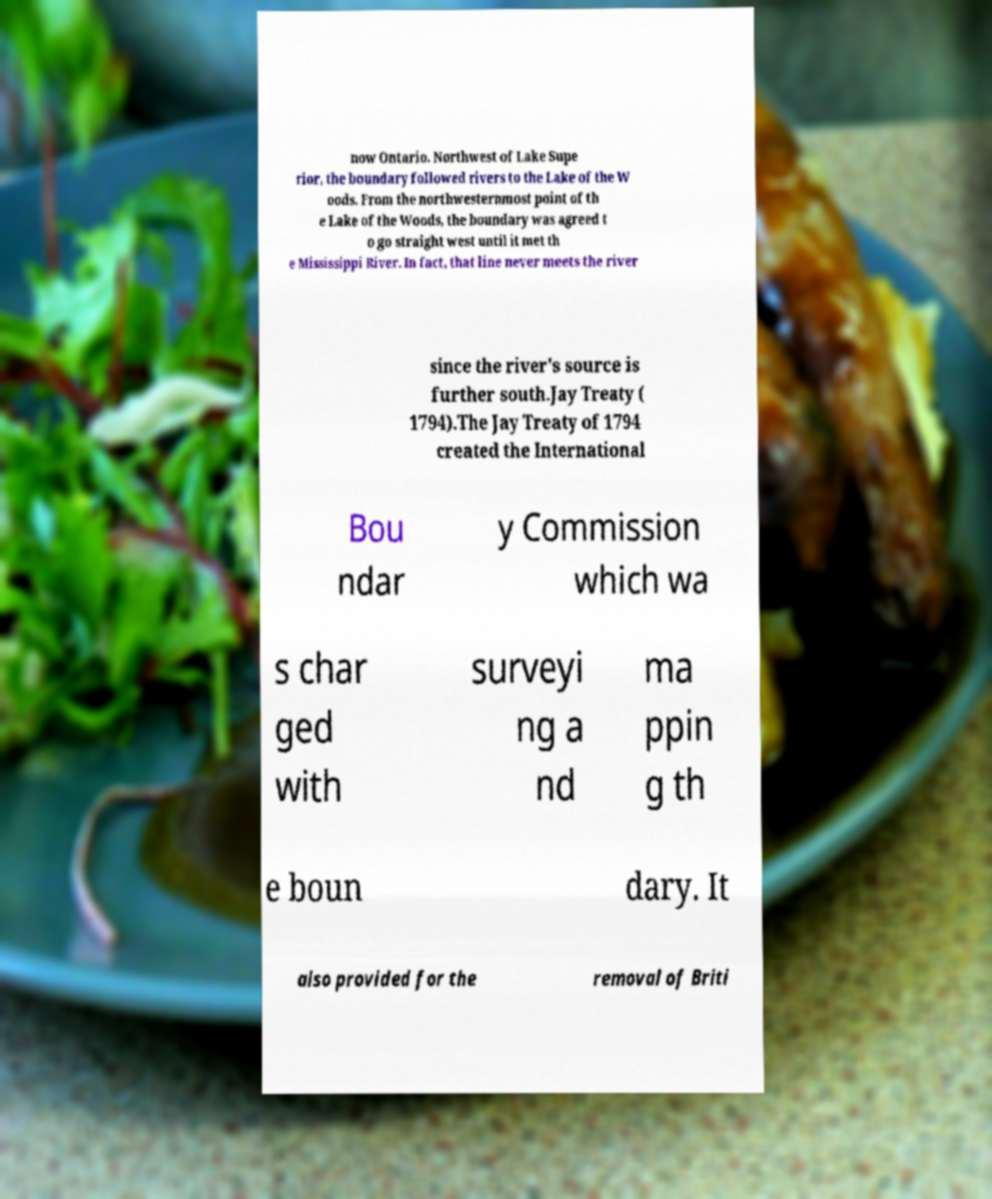Please read and relay the text visible in this image. What does it say? now Ontario. Northwest of Lake Supe rior, the boundary followed rivers to the Lake of the W oods. From the northwesternmost point of th e Lake of the Woods, the boundary was agreed t o go straight west until it met th e Mississippi River. In fact, that line never meets the river since the river's source is further south.Jay Treaty ( 1794).The Jay Treaty of 1794 created the International Bou ndar y Commission which wa s char ged with surveyi ng a nd ma ppin g th e boun dary. It also provided for the removal of Briti 